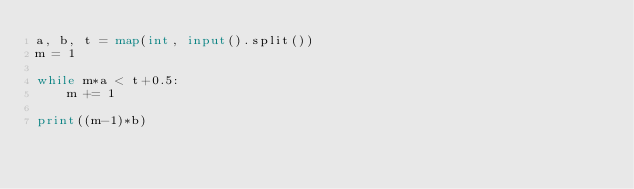<code> <loc_0><loc_0><loc_500><loc_500><_Python_>a, b, t = map(int, input().split())
m = 1

while m*a < t+0.5:
    m += 1

print((m-1)*b)</code> 